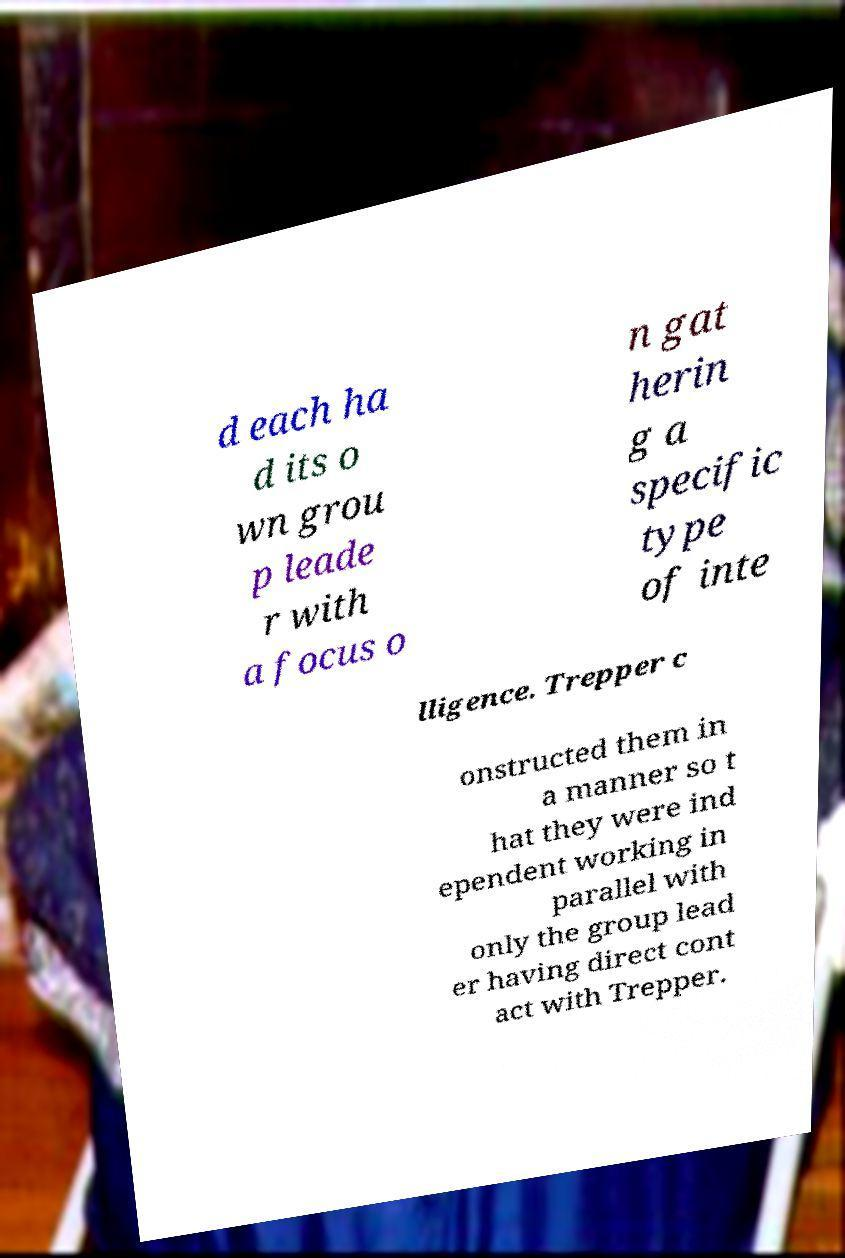Could you extract and type out the text from this image? d each ha d its o wn grou p leade r with a focus o n gat herin g a specific type of inte lligence. Trepper c onstructed them in a manner so t hat they were ind ependent working in parallel with only the group lead er having direct cont act with Trepper. 